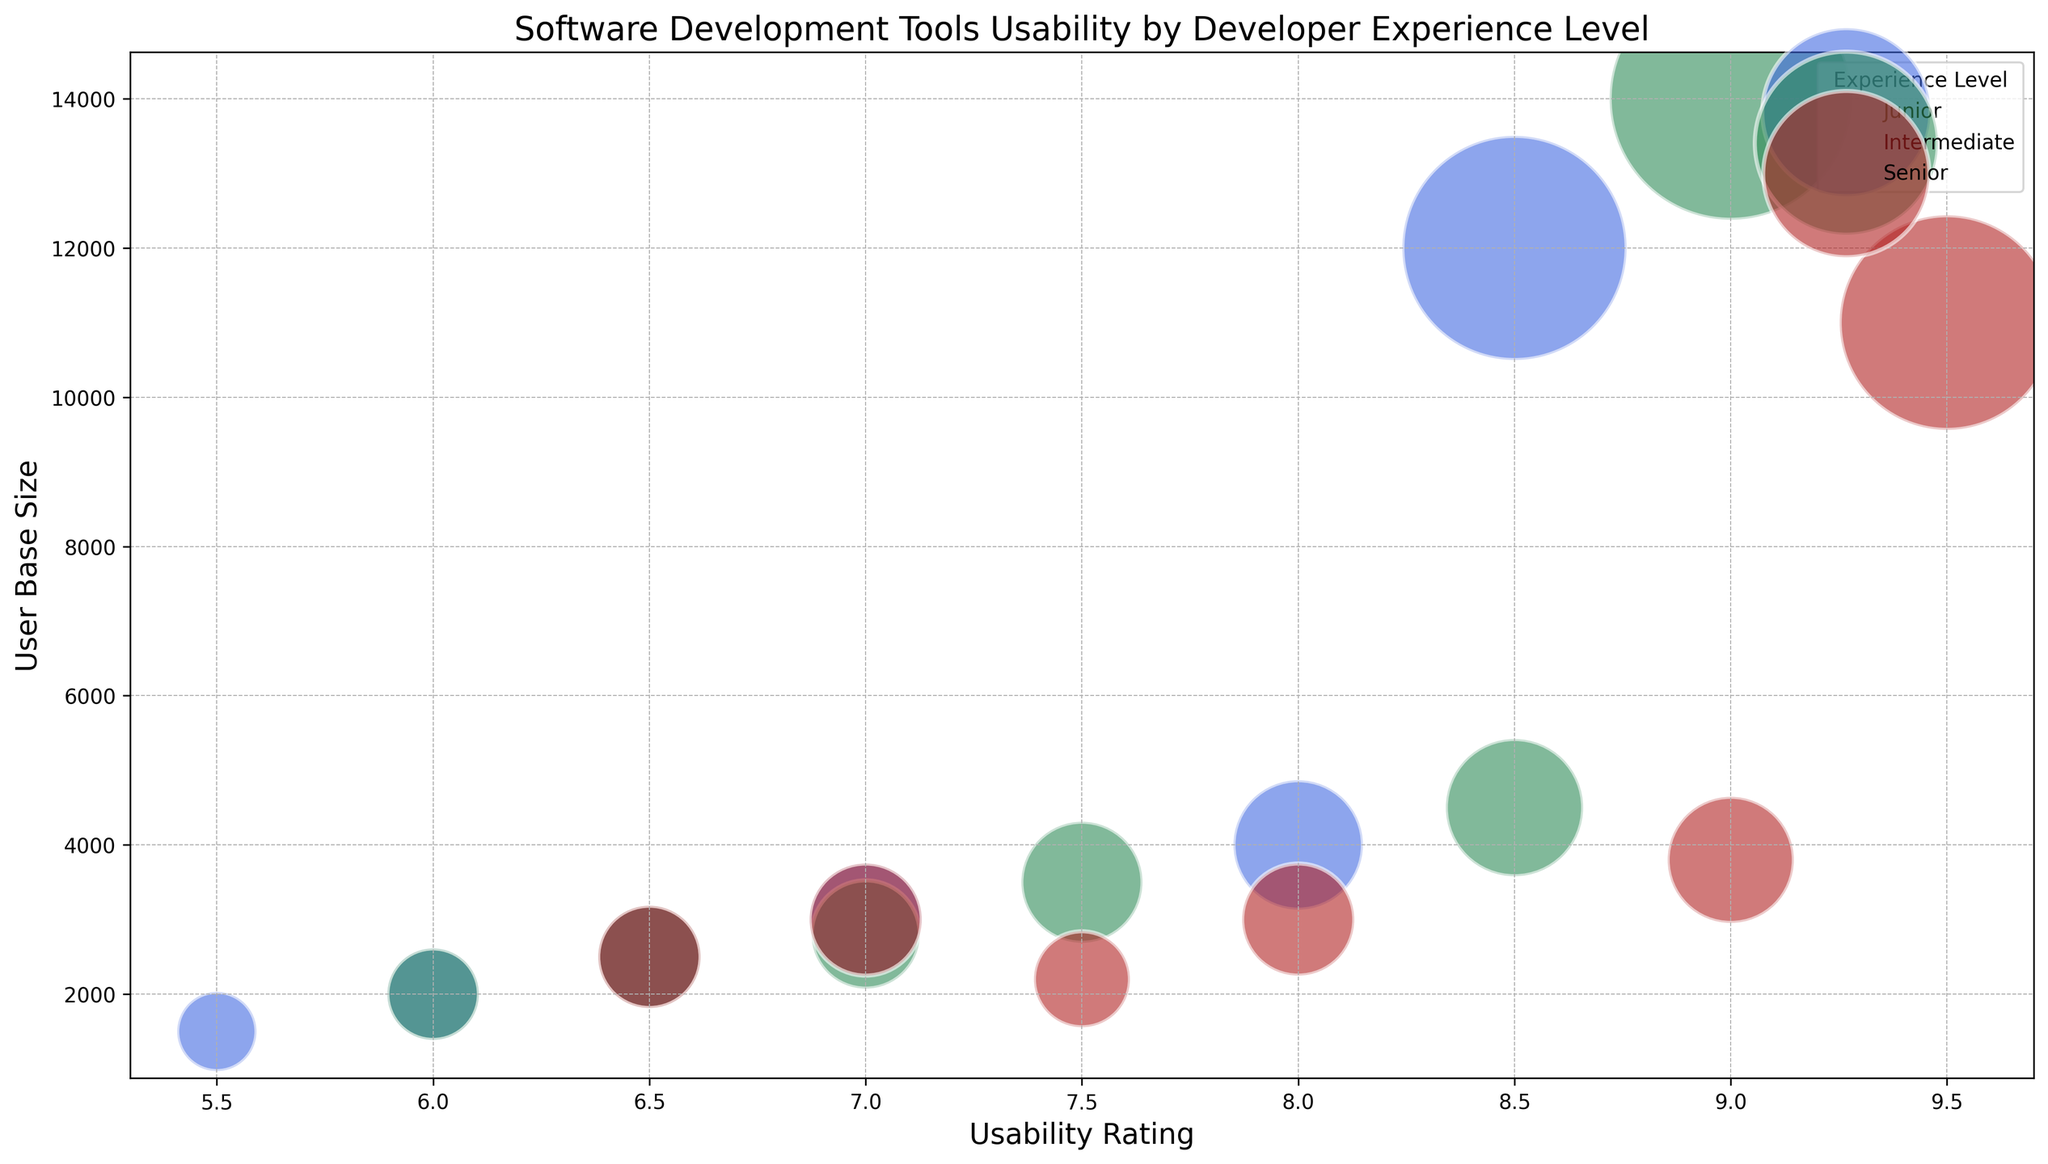What is the usability rating of Visual Studio Code for senior developers? The bubble representing Visual Studio Code for senior developers is located at the intersection of the senior category and the 9.5 usability rating marker on the x-axis.
Answer: 9.5 Which developer experience level has the largest user base size for Sublime Text, and what is the size? By examining the sizes of the bubbles for Sublime Text, the senior developers' bubble is the largest, implying it has the most users. The bubble is located at the intersection of the senior category and the 3000 user base size marker on the y-axis.
Answer: Senior, 3000 Compare the usability ratings of Atom for junior, intermediate, and senior developers. Which one has the highest rating? The usability ratings for Atom are positioned at 6.5 for juniors, 7.0 for intermediates, and 7.5 for seniors.
Answer: Seniors Considering all developer experience levels, which tool has the highest usability rating on the chart? The highest bubble on the x-axis is at 9.5, which corresponds to Visual Studio Code for senior developers.
Answer: Visual Studio Code How does the user base size of IntelliJ IDEA differ between junior and senior developers? The user base size for junior developers using IntelliJ IDEA is 4000, and it is 3800 for senior developers. To find the difference, subtract the senior user base size from the junior one: 4000 - 3800 = 200.
Answer: 200 What is the average usability rating of Eclipse across all experience levels? The usability ratings for Eclipse are 6.0 (junior), 6.5 (intermediate), and 7.0 (senior). Summing these up: 6.0 + 6.5 + 7.0 = 19.5. The average is 19.5 / 3 = 6.5
Answer: 6.5 Which experience level has the smallest bubble size for NetBeans, and what is its user base size? The smallest bubble for NetBeans is in the junior developer category. The user base size for this category is 1500.
Answer: Junior, 1500 Is there any tool that has the same usability rating for different developer experience levels? By inspecting the usability rating positions across different experience levels, the lowest usability rating of 6.5 appears twice: once for Atom (intermediate) and once for Eclipse (intermediate).
Answer: Yes, 6.5 Which tool has shown the greatest increase in usability rating from junior to senior developers? Comparing the difference in usability ratings for each tool from junior to senior levels, Visual Studio Code notably increases from 8.5 to 9.5, a difference of 1.0. Other tools show smaller increases.
Answer: Visual Studio Code 